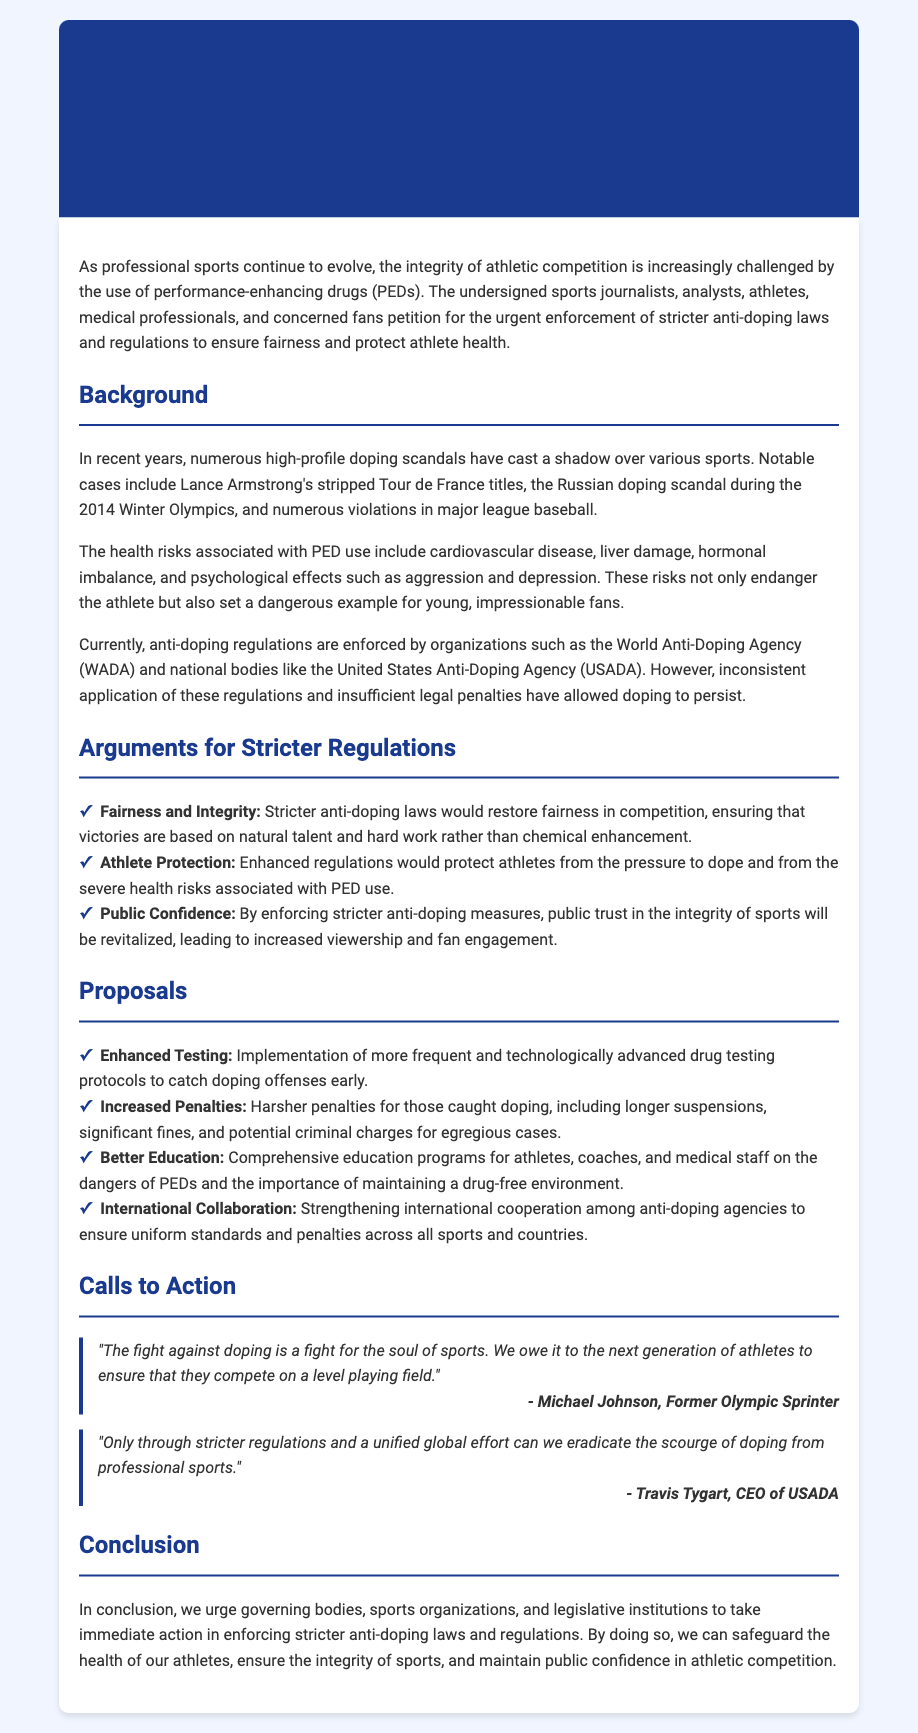What is the title of the petition? The title is found at the top of the document and clearly states the purpose of the petition.
Answer: Petition to Enforce Stricter Anti-Doping Laws and Regulations in Professional Sports Who is quoted as saying, "The fight against doping is a fight for the soul of sports"? The quote is attributed to a well-known athlete mentioned in the document.
Answer: Michael Johnson What major doping scandal is mentioned in the background section? The background section discusses notable cases that have impacted the integrity of sports.
Answer: Russian doping scandal What type of programs are proposed for better education? The document suggests specific actions to improve athlete and coach knowledge on doping.
Answer: Comprehensive education programs How many arguments for stricter regulations are listed? The document contains a specific count of arguments advocating for the need for stricter rules.
Answer: Three What does the petition encourage governing bodies to take immediate action on? The conclusion emphasizes a call for specific responses from organizations overseeing sports.
Answer: Stricter anti-doping laws and regulations What health risks are associated with performance-enhancing drugs? The document highlights specific health issues linked to doping practices in athletes.
Answer: Cardiovascular disease, liver damage, hormonal imbalance, aggression, depression What is one proposed action for enhancing testing? The proposals section outlines specific ways to improve the testing process for doping.
Answer: Implementation of more frequent and technologically advanced drug testing protocols 